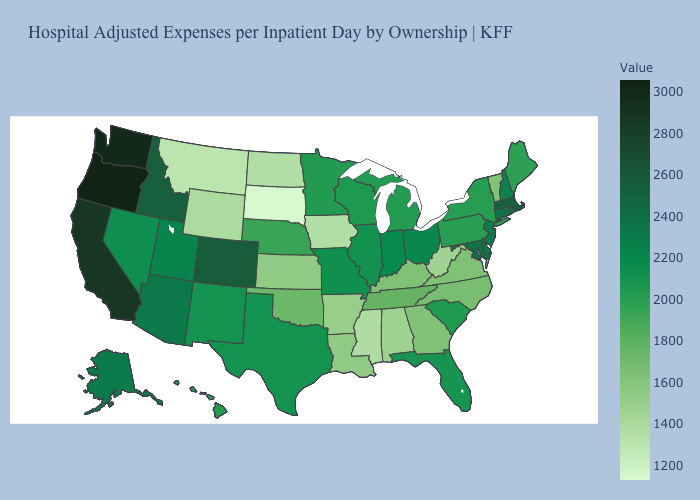Among the states that border Arkansas , does Mississippi have the lowest value?
Quick response, please. Yes. Is the legend a continuous bar?
Quick response, please. Yes. Among the states that border Virginia , which have the lowest value?
Answer briefly. West Virginia. Does Mississippi have the lowest value in the South?
Give a very brief answer. Yes. Does Indiana have a lower value than Iowa?
Be succinct. No. Does Wyoming have the lowest value in the USA?
Be succinct. No. 